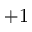<formula> <loc_0><loc_0><loc_500><loc_500>+ 1</formula> 